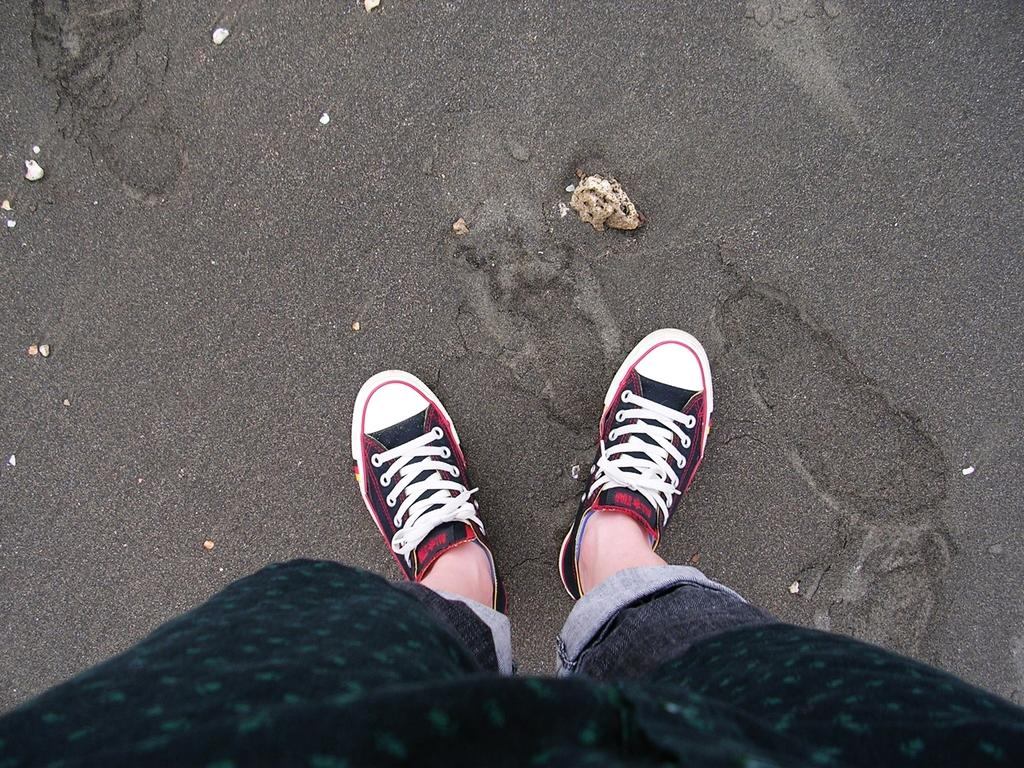What is the person in the image standing on? The person is standing on the sand in the image. What part of the person's body can be seen in the image? The legs of the person are visible. What type of natural elements can be seen in the image? There are stones in the image. What color are the socks the person is wearing in the image? There is no mention of socks in the image, so it cannot be determined what color they might be. 